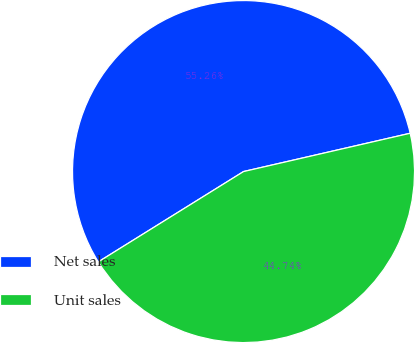Convert chart to OTSL. <chart><loc_0><loc_0><loc_500><loc_500><pie_chart><fcel>Net sales<fcel>Unit sales<nl><fcel>55.26%<fcel>44.74%<nl></chart> 